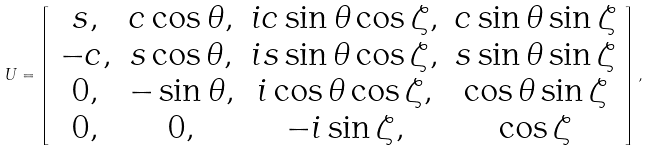Convert formula to latex. <formula><loc_0><loc_0><loc_500><loc_500>U = \left [ \begin{array} { c c c c } { s , } & { { c \cos { \theta } , } } & { i c \sin \theta \cos \zeta , } & { c \sin \theta \sin \zeta } \\ { - c , } & { s \cos \theta , } & { i s \sin \theta \cos \zeta , } & { s \sin \theta \sin \zeta } \\ { 0 , } & { - \sin \theta , } & { i \cos \theta \cos \zeta , } & { \cos \theta \sin \zeta } \\ { 0 , } & { 0 , } & { - i \sin \zeta , } & { \cos \zeta } \end{array} \right ] ,</formula> 